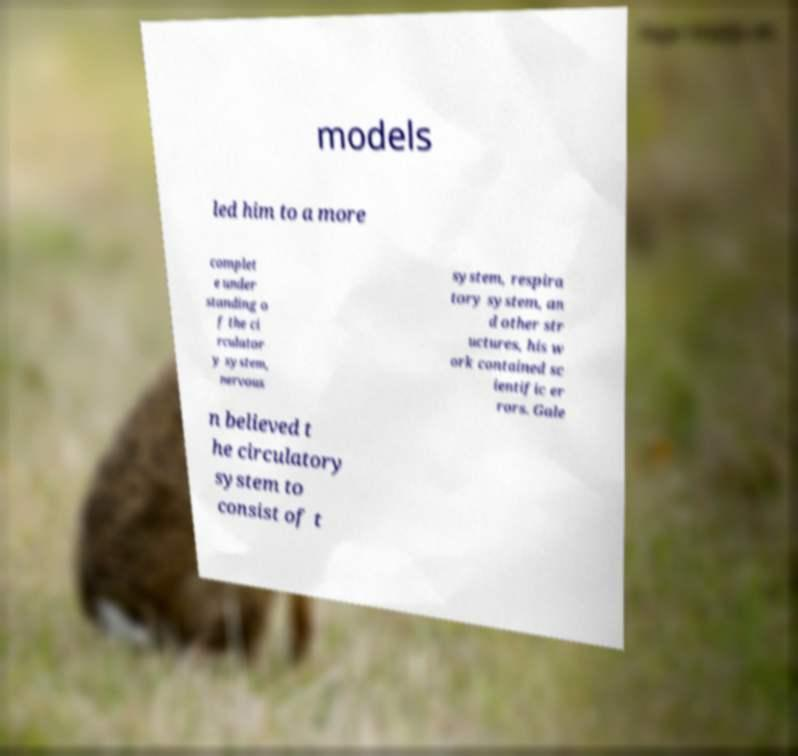There's text embedded in this image that I need extracted. Can you transcribe it verbatim? models led him to a more complet e under standing o f the ci rculator y system, nervous system, respira tory system, an d other str uctures, his w ork contained sc ientific er rors. Gale n believed t he circulatory system to consist of t 